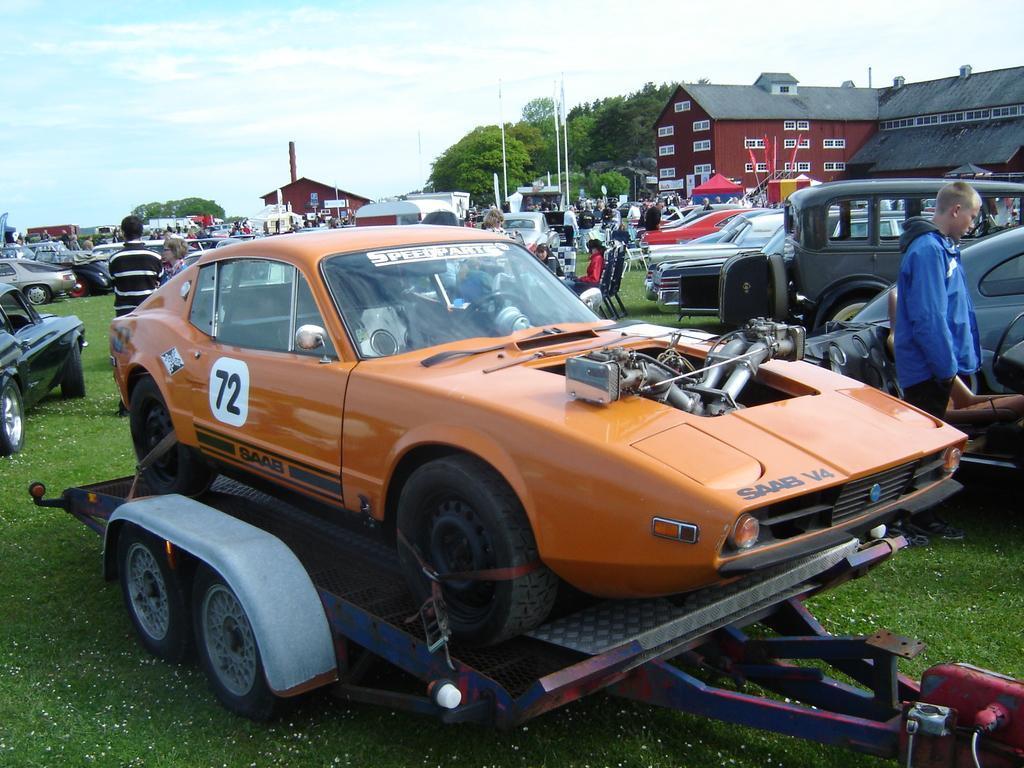Could you give a brief overview of what you see in this image? In this picture we can observe an orange color car placed on this carrier. We can observe some cars parked on the ground. There are some people standing. We can observe a building which is in maroon color on the right side. We can observe white color poles. In the background there are trees and a sky with clouds. 